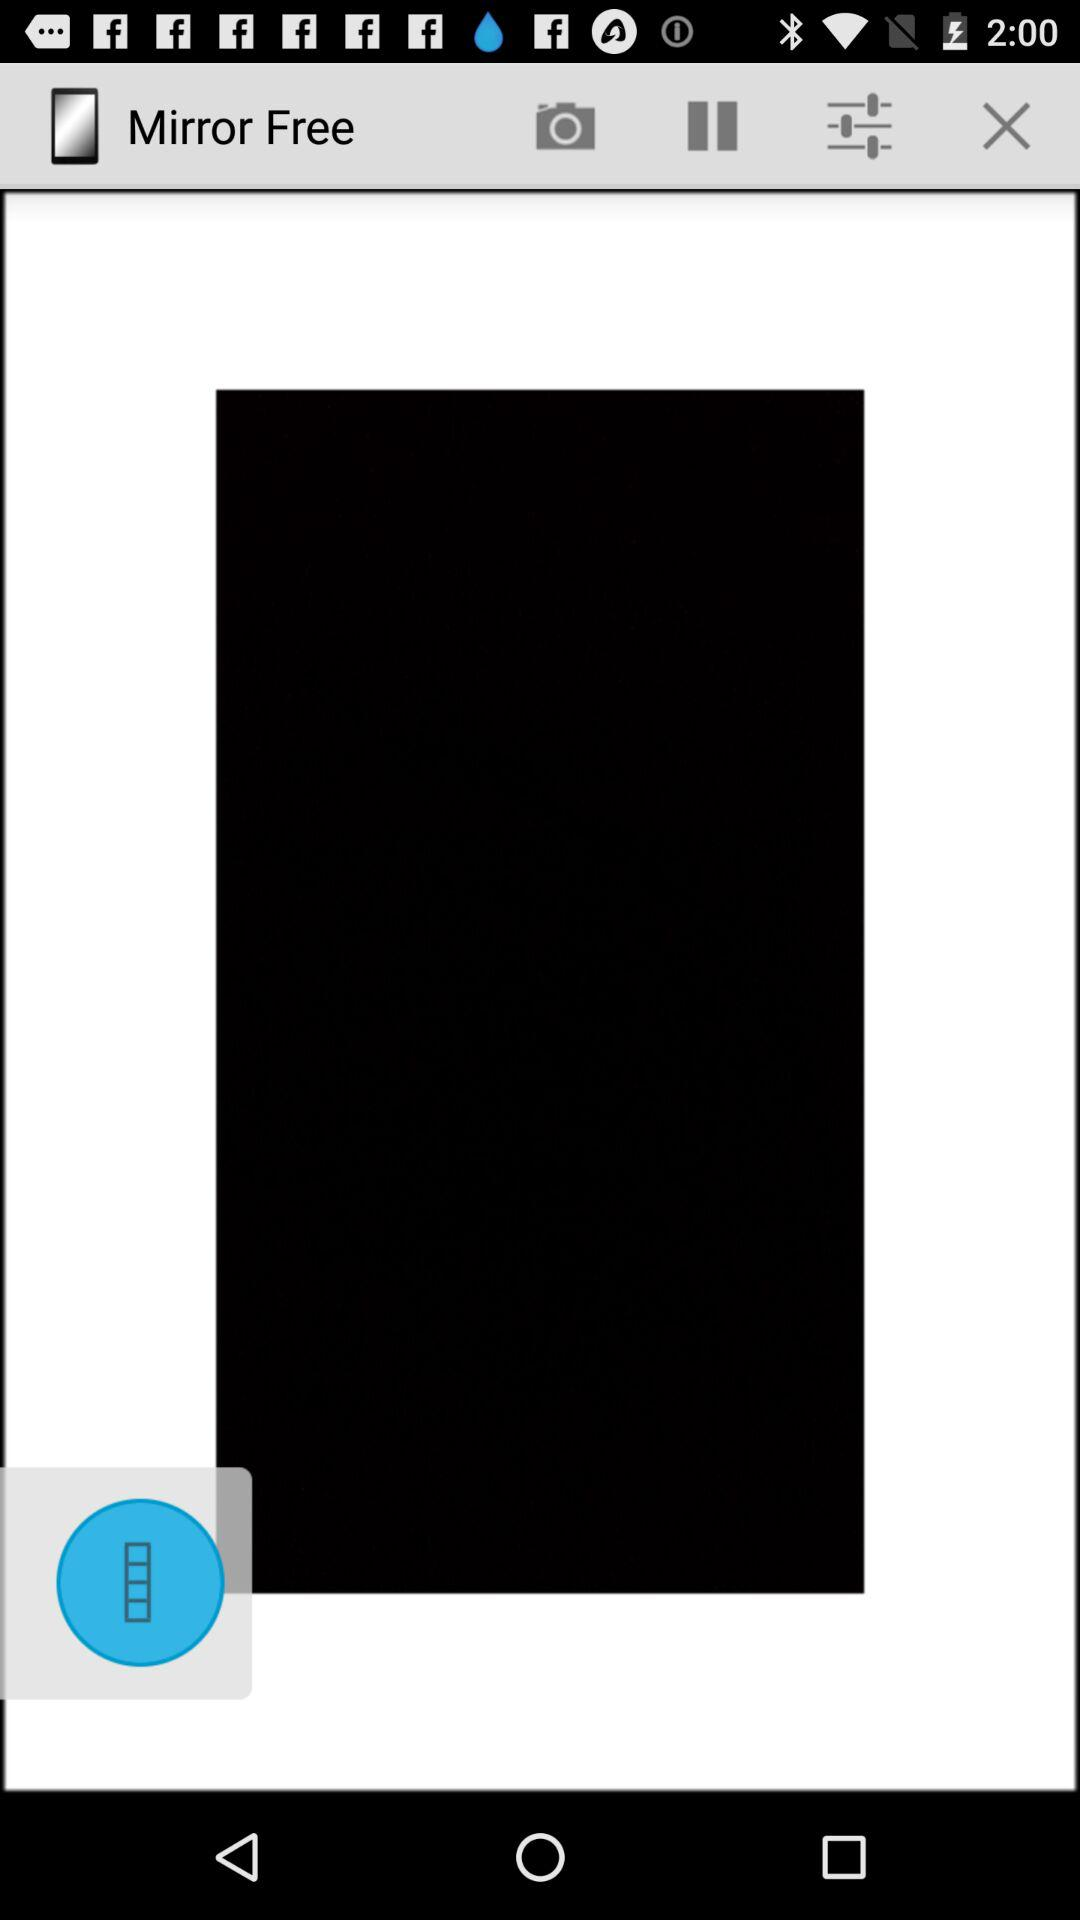What is the application name? The application name is "Mirror Free". 